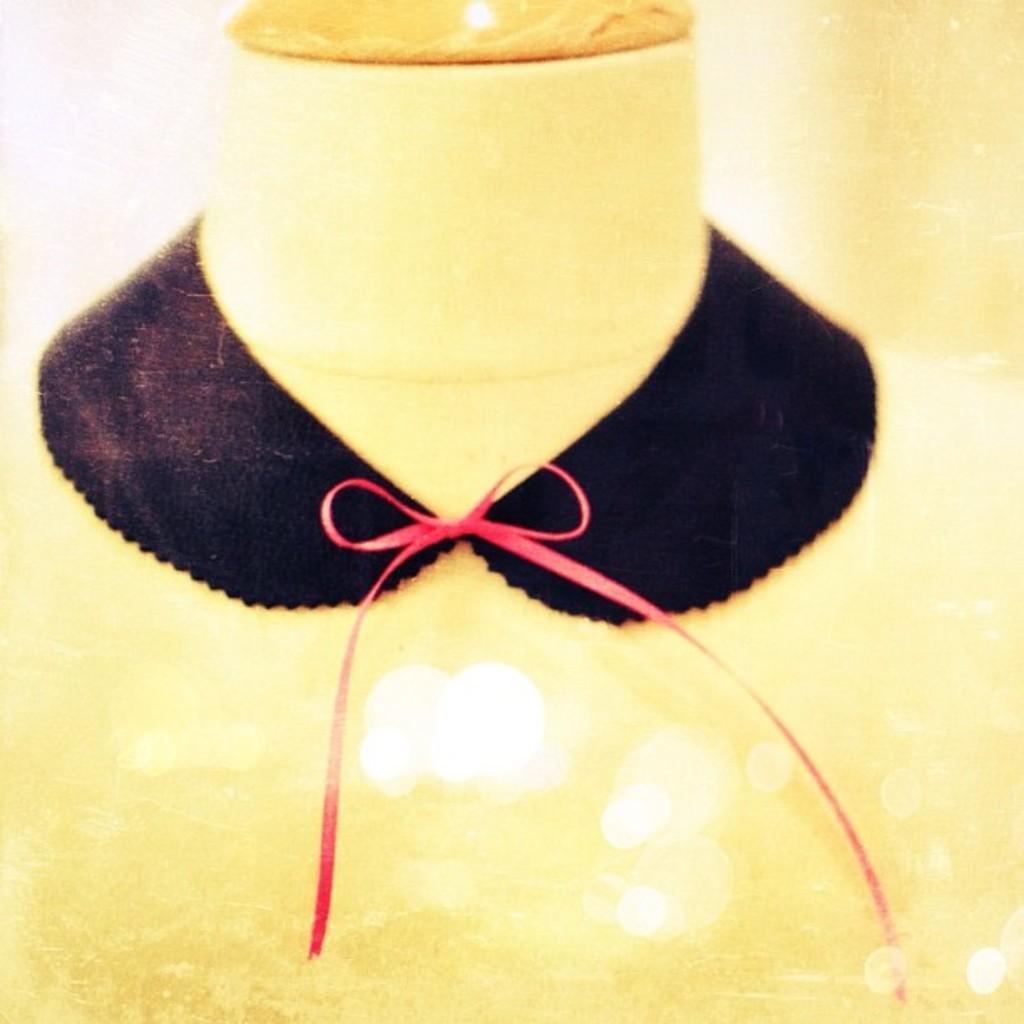How would you summarize this image in a sentence or two? In the image we can see a neck mannequin, on the neck mannequin there is a black cloth and a ribbon. 